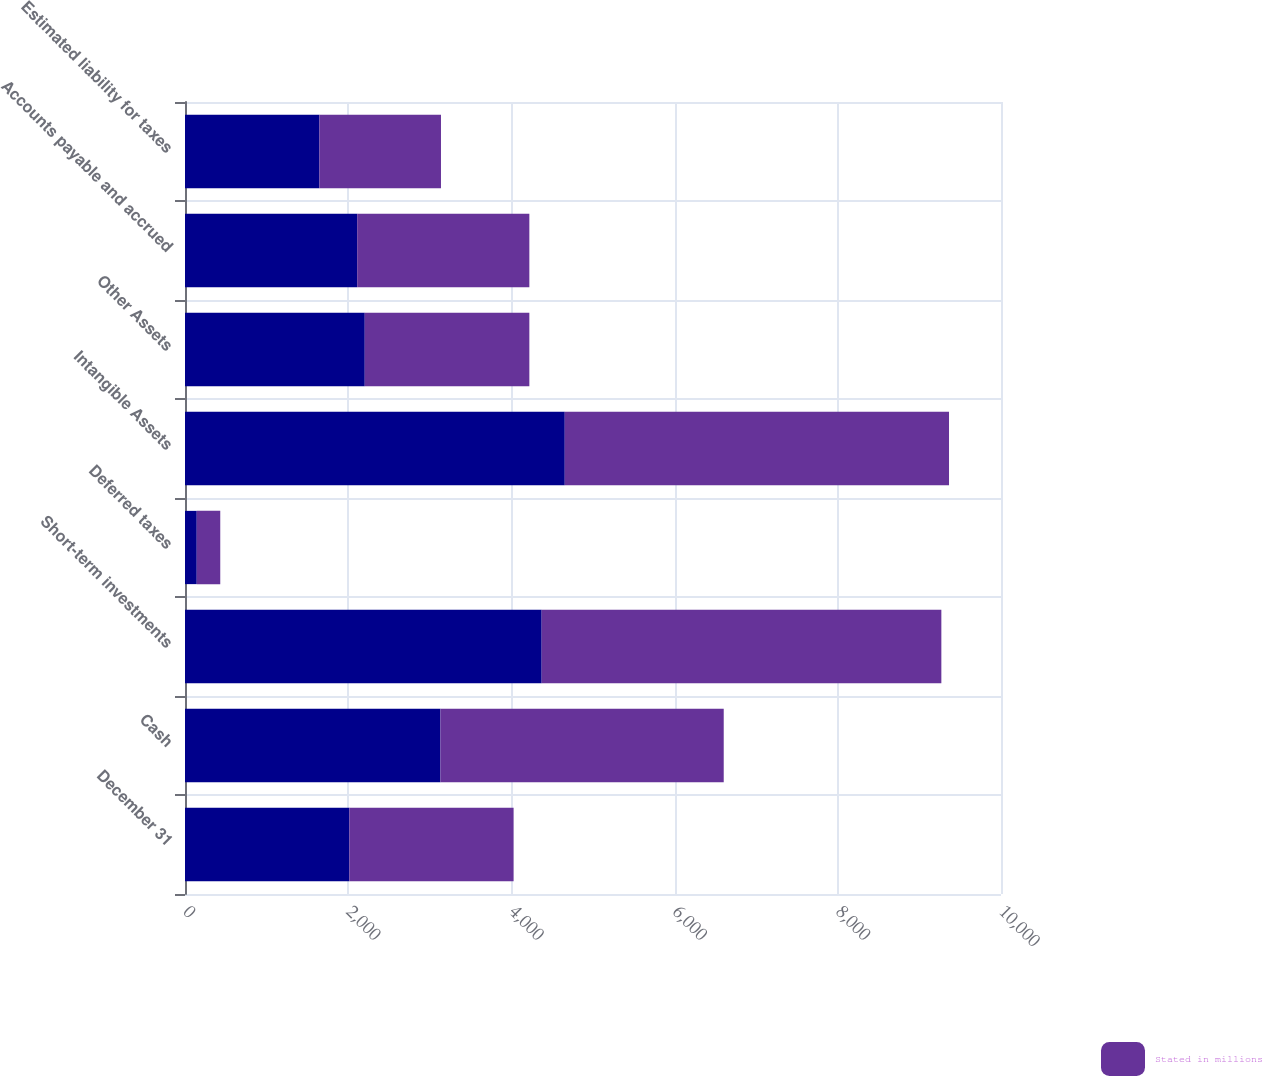<chart> <loc_0><loc_0><loc_500><loc_500><stacked_bar_chart><ecel><fcel>December 31<fcel>Cash<fcel>Short-term investments<fcel>Deferred taxes<fcel>Intangible Assets<fcel>Other Assets<fcel>Accounts payable and accrued<fcel>Estimated liability for taxes<nl><fcel>nan<fcel>2014<fcel>3130<fcel>4371<fcel>144<fcel>4654<fcel>2203<fcel>2110<fcel>1647<nl><fcel>Stated in millions<fcel>2013<fcel>3472<fcel>4898<fcel>288<fcel>4709<fcel>2017<fcel>2110<fcel>1490<nl></chart> 